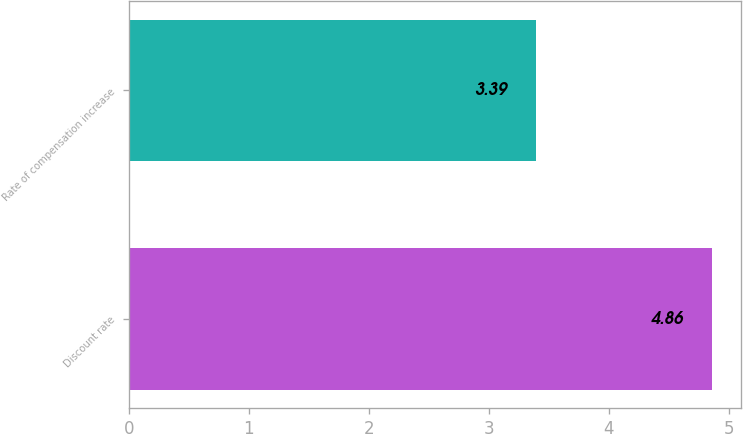<chart> <loc_0><loc_0><loc_500><loc_500><bar_chart><fcel>Discount rate<fcel>Rate of compensation increase<nl><fcel>4.86<fcel>3.39<nl></chart> 